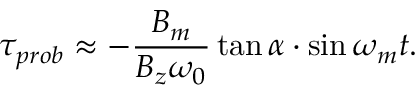Convert formula to latex. <formula><loc_0><loc_0><loc_500><loc_500>\tau _ { p r o b } \approx - \frac { B _ { m } } { B _ { z } \omega _ { 0 } } \tan \alpha \cdot \sin \omega _ { m } t .</formula> 